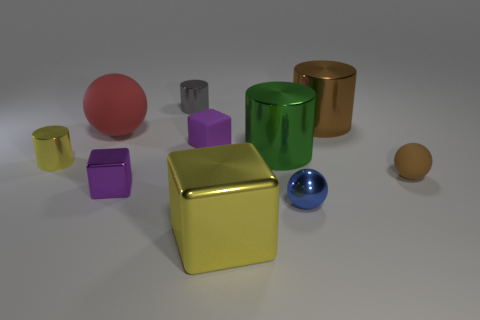Subtract all cylinders. How many objects are left? 6 Add 7 large brown objects. How many large brown objects are left? 8 Add 2 tiny metal objects. How many tiny metal objects exist? 6 Subtract 0 purple balls. How many objects are left? 10 Subtract all small purple metal cubes. Subtract all gray shiny objects. How many objects are left? 8 